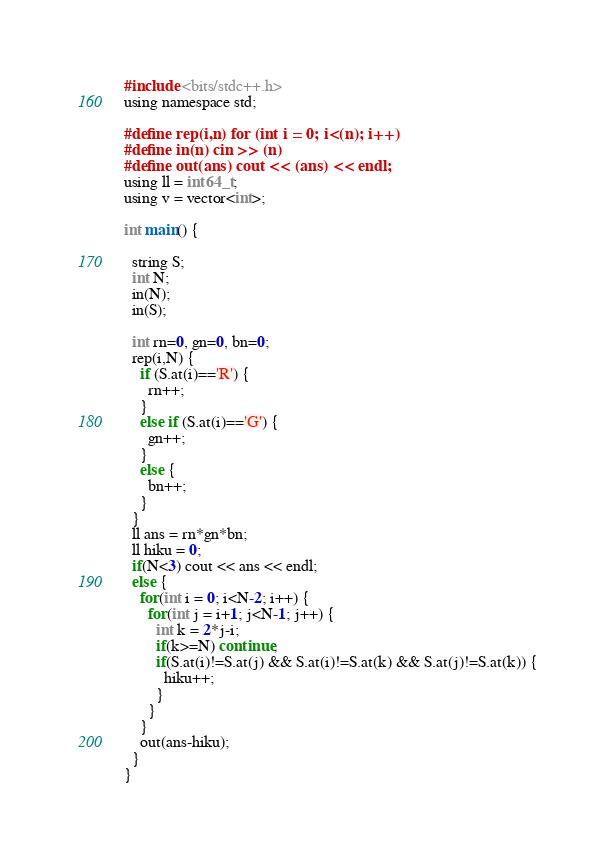Convert code to text. <code><loc_0><loc_0><loc_500><loc_500><_C_>#include <bits/stdc++.h>
using namespace std;
 
#define rep(i,n) for (int i = 0; i<(n); i++)
#define in(n) cin >> (n)
#define out(ans) cout << (ans) << endl;
using ll = int64_t;
using v = vector<int>;

int main() {

  string S;
  int N;
  in(N);
  in(S);
  
  int rn=0, gn=0, bn=0;
  rep(i,N) {
    if (S.at(i)=='R') {
      rn++;
    }
    else if (S.at(i)=='G') {
      gn++;
    }
    else {
      bn++;
    }
  }
  ll ans = rn*gn*bn;
  ll hiku = 0;
  if(N<3) cout << ans << endl;
  else {
    for(int i = 0; i<N-2; i++) {
      for(int j = i+1; j<N-1; j++) {
        int k = 2*j-i;
        if(k>=N) continue;
        if(S.at(i)!=S.at(j) && S.at(i)!=S.at(k) && S.at(j)!=S.at(k)) {
          hiku++;
        }
      }
    }
    out(ans-hiku);
  }
}</code> 